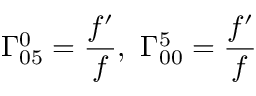<formula> <loc_0><loc_0><loc_500><loc_500>\Gamma _ { 0 5 } ^ { 0 } = \frac { f ^ { \prime } } { f } , \ \Gamma _ { 0 0 } ^ { 5 } = \frac { f ^ { \prime } } { f }</formula> 